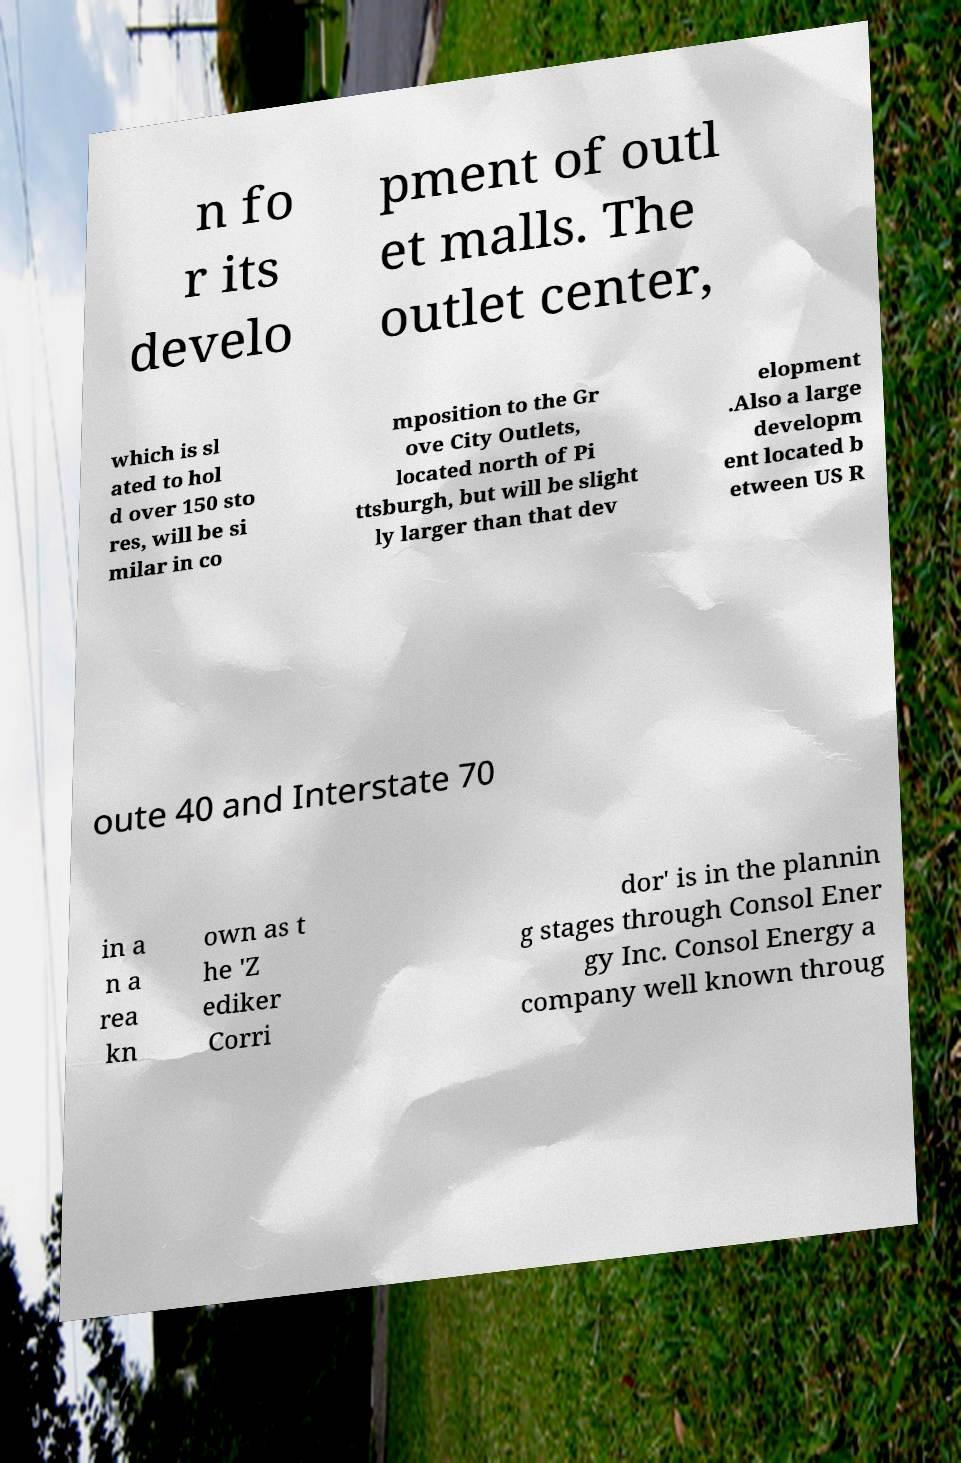What messages or text are displayed in this image? I need them in a readable, typed format. n fo r its develo pment of outl et malls. The outlet center, which is sl ated to hol d over 150 sto res, will be si milar in co mposition to the Gr ove City Outlets, located north of Pi ttsburgh, but will be slight ly larger than that dev elopment .Also a large developm ent located b etween US R oute 40 and Interstate 70 in a n a rea kn own as t he 'Z ediker Corri dor' is in the plannin g stages through Consol Ener gy Inc. Consol Energy a company well known throug 